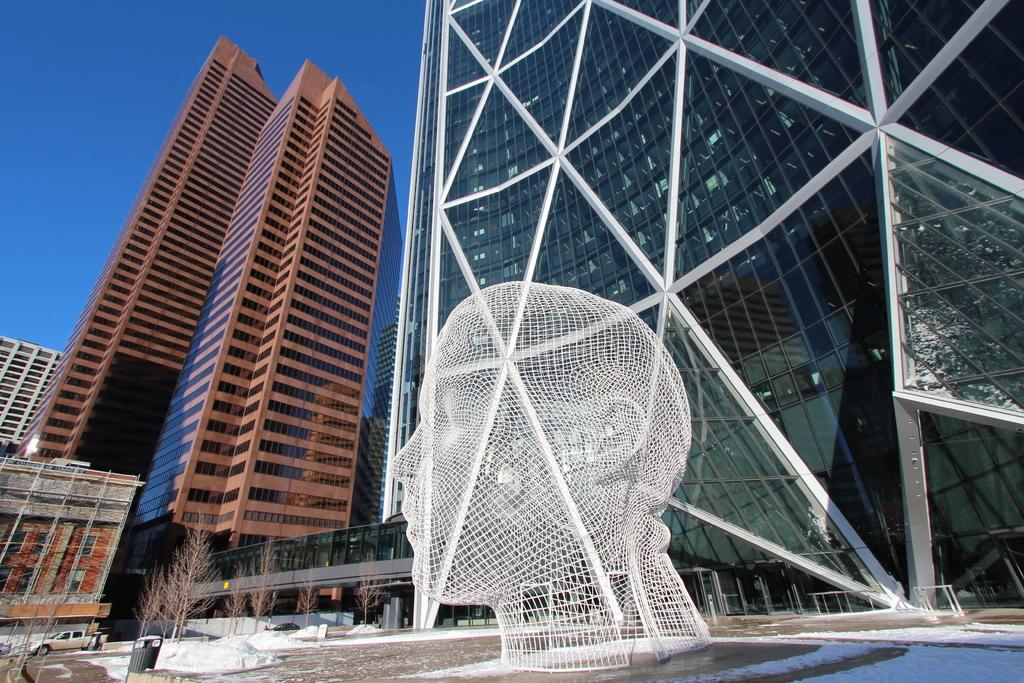What type of structures can be seen in the image? There are buildings in the image. What is the condition of the trees in the image? Dry trees are present in the image. What mode of transportation is visible in the image? A vehicle is visible in the image. Can you describe any other objects in the image? There are objects in the image, but their specific nature is not mentioned in the facts. What is the weather like in the image? Snow is visible in the image, indicating a cold or wintry environment. What is visible in the sky in the image? The sky is visible in the image. Is there any artwork or sculpture in the image? Yes, there is a statue of a person's face in the image. What is the person in the image hoping for? There is no person present in the image, so it is not possible to determine what they might be hoping for. 